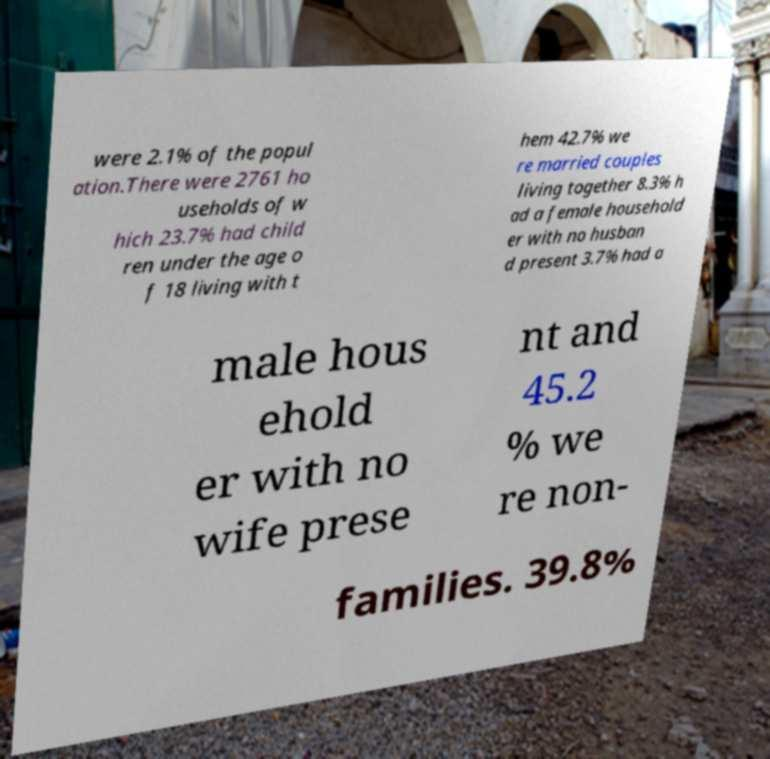Could you assist in decoding the text presented in this image and type it out clearly? were 2.1% of the popul ation.There were 2761 ho useholds of w hich 23.7% had child ren under the age o f 18 living with t hem 42.7% we re married couples living together 8.3% h ad a female household er with no husban d present 3.7% had a male hous ehold er with no wife prese nt and 45.2 % we re non- families. 39.8% 